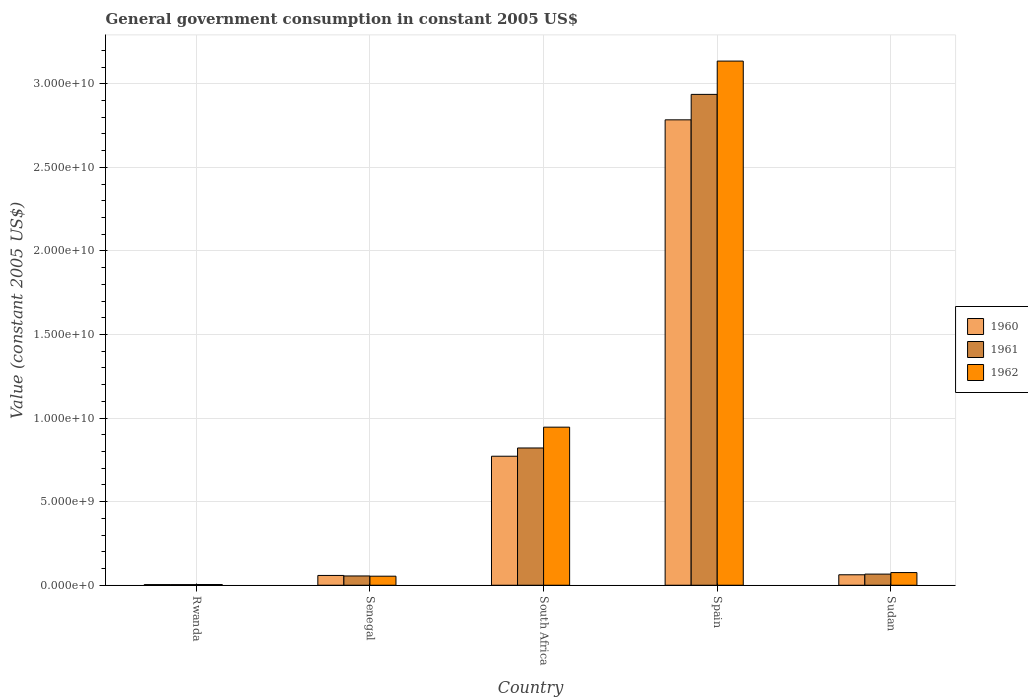Are the number of bars per tick equal to the number of legend labels?
Give a very brief answer. Yes. How many bars are there on the 5th tick from the left?
Ensure brevity in your answer.  3. How many bars are there on the 3rd tick from the right?
Offer a terse response. 3. What is the label of the 1st group of bars from the left?
Give a very brief answer. Rwanda. What is the government conusmption in 1960 in South Africa?
Your response must be concise. 7.72e+09. Across all countries, what is the maximum government conusmption in 1962?
Offer a terse response. 3.14e+1. Across all countries, what is the minimum government conusmption in 1961?
Ensure brevity in your answer.  3.79e+07. In which country was the government conusmption in 1960 minimum?
Ensure brevity in your answer.  Rwanda. What is the total government conusmption in 1960 in the graph?
Offer a terse response. 3.68e+1. What is the difference between the government conusmption in 1961 in Rwanda and that in Senegal?
Your answer should be very brief. -5.17e+08. What is the difference between the government conusmption in 1960 in Rwanda and the government conusmption in 1962 in South Africa?
Offer a very short reply. -9.42e+09. What is the average government conusmption in 1960 per country?
Provide a succinct answer. 7.36e+09. What is the difference between the government conusmption of/in 1961 and government conusmption of/in 1960 in Spain?
Keep it short and to the point. 1.52e+09. In how many countries, is the government conusmption in 1960 greater than 9000000000 US$?
Provide a succinct answer. 1. What is the ratio of the government conusmption in 1961 in Rwanda to that in Sudan?
Provide a succinct answer. 0.06. Is the government conusmption in 1962 in Rwanda less than that in Spain?
Provide a short and direct response. Yes. What is the difference between the highest and the second highest government conusmption in 1960?
Keep it short and to the point. -2.01e+1. What is the difference between the highest and the lowest government conusmption in 1960?
Offer a very short reply. 2.78e+1. What does the 1st bar from the left in Senegal represents?
Your response must be concise. 1960. What does the 1st bar from the right in Rwanda represents?
Make the answer very short. 1962. Is it the case that in every country, the sum of the government conusmption in 1962 and government conusmption in 1960 is greater than the government conusmption in 1961?
Give a very brief answer. Yes. What is the difference between two consecutive major ticks on the Y-axis?
Keep it short and to the point. 5.00e+09. Are the values on the major ticks of Y-axis written in scientific E-notation?
Give a very brief answer. Yes. Does the graph contain grids?
Provide a succinct answer. Yes. Where does the legend appear in the graph?
Keep it short and to the point. Center right. How many legend labels are there?
Ensure brevity in your answer.  3. What is the title of the graph?
Provide a succinct answer. General government consumption in constant 2005 US$. Does "1985" appear as one of the legend labels in the graph?
Offer a terse response. No. What is the label or title of the X-axis?
Provide a short and direct response. Country. What is the label or title of the Y-axis?
Your answer should be very brief. Value (constant 2005 US$). What is the Value (constant 2005 US$) of 1960 in Rwanda?
Ensure brevity in your answer.  3.93e+07. What is the Value (constant 2005 US$) of 1961 in Rwanda?
Your answer should be very brief. 3.79e+07. What is the Value (constant 2005 US$) in 1962 in Rwanda?
Offer a very short reply. 4.39e+07. What is the Value (constant 2005 US$) of 1960 in Senegal?
Offer a very short reply. 5.86e+08. What is the Value (constant 2005 US$) of 1961 in Senegal?
Offer a terse response. 5.55e+08. What is the Value (constant 2005 US$) in 1962 in Senegal?
Offer a very short reply. 5.41e+08. What is the Value (constant 2005 US$) in 1960 in South Africa?
Provide a short and direct response. 7.72e+09. What is the Value (constant 2005 US$) of 1961 in South Africa?
Your answer should be compact. 8.21e+09. What is the Value (constant 2005 US$) in 1962 in South Africa?
Make the answer very short. 9.46e+09. What is the Value (constant 2005 US$) of 1960 in Spain?
Offer a terse response. 2.78e+1. What is the Value (constant 2005 US$) of 1961 in Spain?
Your answer should be compact. 2.94e+1. What is the Value (constant 2005 US$) of 1962 in Spain?
Provide a succinct answer. 3.14e+1. What is the Value (constant 2005 US$) in 1960 in Sudan?
Your answer should be compact. 6.26e+08. What is the Value (constant 2005 US$) in 1961 in Sudan?
Your answer should be very brief. 6.66e+08. What is the Value (constant 2005 US$) of 1962 in Sudan?
Offer a terse response. 7.58e+08. Across all countries, what is the maximum Value (constant 2005 US$) of 1960?
Ensure brevity in your answer.  2.78e+1. Across all countries, what is the maximum Value (constant 2005 US$) of 1961?
Offer a terse response. 2.94e+1. Across all countries, what is the maximum Value (constant 2005 US$) of 1962?
Offer a very short reply. 3.14e+1. Across all countries, what is the minimum Value (constant 2005 US$) in 1960?
Give a very brief answer. 3.93e+07. Across all countries, what is the minimum Value (constant 2005 US$) in 1961?
Your response must be concise. 3.79e+07. Across all countries, what is the minimum Value (constant 2005 US$) in 1962?
Make the answer very short. 4.39e+07. What is the total Value (constant 2005 US$) in 1960 in the graph?
Make the answer very short. 3.68e+1. What is the total Value (constant 2005 US$) in 1961 in the graph?
Offer a very short reply. 3.88e+1. What is the total Value (constant 2005 US$) in 1962 in the graph?
Keep it short and to the point. 4.22e+1. What is the difference between the Value (constant 2005 US$) of 1960 in Rwanda and that in Senegal?
Keep it short and to the point. -5.47e+08. What is the difference between the Value (constant 2005 US$) of 1961 in Rwanda and that in Senegal?
Ensure brevity in your answer.  -5.17e+08. What is the difference between the Value (constant 2005 US$) in 1962 in Rwanda and that in Senegal?
Provide a succinct answer. -4.97e+08. What is the difference between the Value (constant 2005 US$) in 1960 in Rwanda and that in South Africa?
Make the answer very short. -7.68e+09. What is the difference between the Value (constant 2005 US$) of 1961 in Rwanda and that in South Africa?
Offer a terse response. -8.17e+09. What is the difference between the Value (constant 2005 US$) in 1962 in Rwanda and that in South Africa?
Give a very brief answer. -9.41e+09. What is the difference between the Value (constant 2005 US$) of 1960 in Rwanda and that in Spain?
Your response must be concise. -2.78e+1. What is the difference between the Value (constant 2005 US$) of 1961 in Rwanda and that in Spain?
Provide a short and direct response. -2.93e+1. What is the difference between the Value (constant 2005 US$) of 1962 in Rwanda and that in Spain?
Keep it short and to the point. -3.13e+1. What is the difference between the Value (constant 2005 US$) in 1960 in Rwanda and that in Sudan?
Make the answer very short. -5.86e+08. What is the difference between the Value (constant 2005 US$) of 1961 in Rwanda and that in Sudan?
Provide a succinct answer. -6.28e+08. What is the difference between the Value (constant 2005 US$) in 1962 in Rwanda and that in Sudan?
Ensure brevity in your answer.  -7.14e+08. What is the difference between the Value (constant 2005 US$) of 1960 in Senegal and that in South Africa?
Make the answer very short. -7.13e+09. What is the difference between the Value (constant 2005 US$) of 1961 in Senegal and that in South Africa?
Your response must be concise. -7.66e+09. What is the difference between the Value (constant 2005 US$) of 1962 in Senegal and that in South Africa?
Offer a terse response. -8.92e+09. What is the difference between the Value (constant 2005 US$) in 1960 in Senegal and that in Spain?
Your answer should be compact. -2.73e+1. What is the difference between the Value (constant 2005 US$) in 1961 in Senegal and that in Spain?
Your response must be concise. -2.88e+1. What is the difference between the Value (constant 2005 US$) of 1962 in Senegal and that in Spain?
Your answer should be very brief. -3.08e+1. What is the difference between the Value (constant 2005 US$) of 1960 in Senegal and that in Sudan?
Provide a succinct answer. -3.97e+07. What is the difference between the Value (constant 2005 US$) of 1961 in Senegal and that in Sudan?
Offer a terse response. -1.11e+08. What is the difference between the Value (constant 2005 US$) in 1962 in Senegal and that in Sudan?
Offer a terse response. -2.17e+08. What is the difference between the Value (constant 2005 US$) of 1960 in South Africa and that in Spain?
Provide a short and direct response. -2.01e+1. What is the difference between the Value (constant 2005 US$) of 1961 in South Africa and that in Spain?
Provide a short and direct response. -2.12e+1. What is the difference between the Value (constant 2005 US$) in 1962 in South Africa and that in Spain?
Offer a very short reply. -2.19e+1. What is the difference between the Value (constant 2005 US$) in 1960 in South Africa and that in Sudan?
Make the answer very short. 7.09e+09. What is the difference between the Value (constant 2005 US$) of 1961 in South Africa and that in Sudan?
Keep it short and to the point. 7.55e+09. What is the difference between the Value (constant 2005 US$) in 1962 in South Africa and that in Sudan?
Offer a very short reply. 8.70e+09. What is the difference between the Value (constant 2005 US$) of 1960 in Spain and that in Sudan?
Keep it short and to the point. 2.72e+1. What is the difference between the Value (constant 2005 US$) in 1961 in Spain and that in Sudan?
Keep it short and to the point. 2.87e+1. What is the difference between the Value (constant 2005 US$) of 1962 in Spain and that in Sudan?
Ensure brevity in your answer.  3.06e+1. What is the difference between the Value (constant 2005 US$) of 1960 in Rwanda and the Value (constant 2005 US$) of 1961 in Senegal?
Keep it short and to the point. -5.16e+08. What is the difference between the Value (constant 2005 US$) of 1960 in Rwanda and the Value (constant 2005 US$) of 1962 in Senegal?
Your answer should be compact. -5.01e+08. What is the difference between the Value (constant 2005 US$) in 1961 in Rwanda and the Value (constant 2005 US$) in 1962 in Senegal?
Offer a very short reply. -5.03e+08. What is the difference between the Value (constant 2005 US$) of 1960 in Rwanda and the Value (constant 2005 US$) of 1961 in South Africa?
Offer a terse response. -8.17e+09. What is the difference between the Value (constant 2005 US$) of 1960 in Rwanda and the Value (constant 2005 US$) of 1962 in South Africa?
Provide a succinct answer. -9.42e+09. What is the difference between the Value (constant 2005 US$) in 1961 in Rwanda and the Value (constant 2005 US$) in 1962 in South Africa?
Your answer should be very brief. -9.42e+09. What is the difference between the Value (constant 2005 US$) in 1960 in Rwanda and the Value (constant 2005 US$) in 1961 in Spain?
Offer a very short reply. -2.93e+1. What is the difference between the Value (constant 2005 US$) of 1960 in Rwanda and the Value (constant 2005 US$) of 1962 in Spain?
Keep it short and to the point. -3.13e+1. What is the difference between the Value (constant 2005 US$) of 1961 in Rwanda and the Value (constant 2005 US$) of 1962 in Spain?
Offer a terse response. -3.13e+1. What is the difference between the Value (constant 2005 US$) in 1960 in Rwanda and the Value (constant 2005 US$) in 1961 in Sudan?
Your answer should be very brief. -6.27e+08. What is the difference between the Value (constant 2005 US$) of 1960 in Rwanda and the Value (constant 2005 US$) of 1962 in Sudan?
Make the answer very short. -7.19e+08. What is the difference between the Value (constant 2005 US$) of 1961 in Rwanda and the Value (constant 2005 US$) of 1962 in Sudan?
Keep it short and to the point. -7.20e+08. What is the difference between the Value (constant 2005 US$) in 1960 in Senegal and the Value (constant 2005 US$) in 1961 in South Africa?
Your answer should be compact. -7.63e+09. What is the difference between the Value (constant 2005 US$) of 1960 in Senegal and the Value (constant 2005 US$) of 1962 in South Africa?
Keep it short and to the point. -8.87e+09. What is the difference between the Value (constant 2005 US$) in 1961 in Senegal and the Value (constant 2005 US$) in 1962 in South Africa?
Offer a very short reply. -8.90e+09. What is the difference between the Value (constant 2005 US$) in 1960 in Senegal and the Value (constant 2005 US$) in 1961 in Spain?
Make the answer very short. -2.88e+1. What is the difference between the Value (constant 2005 US$) in 1960 in Senegal and the Value (constant 2005 US$) in 1962 in Spain?
Ensure brevity in your answer.  -3.08e+1. What is the difference between the Value (constant 2005 US$) in 1961 in Senegal and the Value (constant 2005 US$) in 1962 in Spain?
Give a very brief answer. -3.08e+1. What is the difference between the Value (constant 2005 US$) in 1960 in Senegal and the Value (constant 2005 US$) in 1961 in Sudan?
Your answer should be very brief. -8.05e+07. What is the difference between the Value (constant 2005 US$) of 1960 in Senegal and the Value (constant 2005 US$) of 1962 in Sudan?
Ensure brevity in your answer.  -1.72e+08. What is the difference between the Value (constant 2005 US$) of 1961 in Senegal and the Value (constant 2005 US$) of 1962 in Sudan?
Your response must be concise. -2.03e+08. What is the difference between the Value (constant 2005 US$) in 1960 in South Africa and the Value (constant 2005 US$) in 1961 in Spain?
Keep it short and to the point. -2.16e+1. What is the difference between the Value (constant 2005 US$) in 1960 in South Africa and the Value (constant 2005 US$) in 1962 in Spain?
Your response must be concise. -2.36e+1. What is the difference between the Value (constant 2005 US$) of 1961 in South Africa and the Value (constant 2005 US$) of 1962 in Spain?
Provide a succinct answer. -2.31e+1. What is the difference between the Value (constant 2005 US$) of 1960 in South Africa and the Value (constant 2005 US$) of 1961 in Sudan?
Give a very brief answer. 7.05e+09. What is the difference between the Value (constant 2005 US$) in 1960 in South Africa and the Value (constant 2005 US$) in 1962 in Sudan?
Your response must be concise. 6.96e+09. What is the difference between the Value (constant 2005 US$) of 1961 in South Africa and the Value (constant 2005 US$) of 1962 in Sudan?
Offer a terse response. 7.45e+09. What is the difference between the Value (constant 2005 US$) in 1960 in Spain and the Value (constant 2005 US$) in 1961 in Sudan?
Offer a terse response. 2.72e+1. What is the difference between the Value (constant 2005 US$) in 1960 in Spain and the Value (constant 2005 US$) in 1962 in Sudan?
Keep it short and to the point. 2.71e+1. What is the difference between the Value (constant 2005 US$) of 1961 in Spain and the Value (constant 2005 US$) of 1962 in Sudan?
Provide a succinct answer. 2.86e+1. What is the average Value (constant 2005 US$) of 1960 per country?
Ensure brevity in your answer.  7.36e+09. What is the average Value (constant 2005 US$) in 1961 per country?
Provide a short and direct response. 7.77e+09. What is the average Value (constant 2005 US$) in 1962 per country?
Provide a succinct answer. 8.43e+09. What is the difference between the Value (constant 2005 US$) of 1960 and Value (constant 2005 US$) of 1961 in Rwanda?
Provide a succinct answer. 1.39e+06. What is the difference between the Value (constant 2005 US$) of 1960 and Value (constant 2005 US$) of 1962 in Rwanda?
Make the answer very short. -4.55e+06. What is the difference between the Value (constant 2005 US$) in 1961 and Value (constant 2005 US$) in 1962 in Rwanda?
Make the answer very short. -5.95e+06. What is the difference between the Value (constant 2005 US$) of 1960 and Value (constant 2005 US$) of 1961 in Senegal?
Your response must be concise. 3.05e+07. What is the difference between the Value (constant 2005 US$) of 1960 and Value (constant 2005 US$) of 1962 in Senegal?
Make the answer very short. 4.51e+07. What is the difference between the Value (constant 2005 US$) of 1961 and Value (constant 2005 US$) of 1962 in Senegal?
Offer a terse response. 1.45e+07. What is the difference between the Value (constant 2005 US$) in 1960 and Value (constant 2005 US$) in 1961 in South Africa?
Provide a succinct answer. -4.93e+08. What is the difference between the Value (constant 2005 US$) of 1960 and Value (constant 2005 US$) of 1962 in South Africa?
Your answer should be very brief. -1.74e+09. What is the difference between the Value (constant 2005 US$) of 1961 and Value (constant 2005 US$) of 1962 in South Africa?
Provide a short and direct response. -1.25e+09. What is the difference between the Value (constant 2005 US$) in 1960 and Value (constant 2005 US$) in 1961 in Spain?
Your answer should be compact. -1.52e+09. What is the difference between the Value (constant 2005 US$) of 1960 and Value (constant 2005 US$) of 1962 in Spain?
Keep it short and to the point. -3.51e+09. What is the difference between the Value (constant 2005 US$) in 1961 and Value (constant 2005 US$) in 1962 in Spain?
Provide a short and direct response. -1.99e+09. What is the difference between the Value (constant 2005 US$) of 1960 and Value (constant 2005 US$) of 1961 in Sudan?
Make the answer very short. -4.08e+07. What is the difference between the Value (constant 2005 US$) in 1960 and Value (constant 2005 US$) in 1962 in Sudan?
Provide a succinct answer. -1.33e+08. What is the difference between the Value (constant 2005 US$) in 1961 and Value (constant 2005 US$) in 1962 in Sudan?
Make the answer very short. -9.18e+07. What is the ratio of the Value (constant 2005 US$) of 1960 in Rwanda to that in Senegal?
Provide a succinct answer. 0.07. What is the ratio of the Value (constant 2005 US$) of 1961 in Rwanda to that in Senegal?
Offer a terse response. 0.07. What is the ratio of the Value (constant 2005 US$) in 1962 in Rwanda to that in Senegal?
Make the answer very short. 0.08. What is the ratio of the Value (constant 2005 US$) in 1960 in Rwanda to that in South Africa?
Your answer should be very brief. 0.01. What is the ratio of the Value (constant 2005 US$) of 1961 in Rwanda to that in South Africa?
Offer a terse response. 0. What is the ratio of the Value (constant 2005 US$) in 1962 in Rwanda to that in South Africa?
Your answer should be compact. 0. What is the ratio of the Value (constant 2005 US$) in 1960 in Rwanda to that in Spain?
Your answer should be compact. 0. What is the ratio of the Value (constant 2005 US$) of 1961 in Rwanda to that in Spain?
Your answer should be compact. 0. What is the ratio of the Value (constant 2005 US$) of 1962 in Rwanda to that in Spain?
Provide a succinct answer. 0. What is the ratio of the Value (constant 2005 US$) of 1960 in Rwanda to that in Sudan?
Give a very brief answer. 0.06. What is the ratio of the Value (constant 2005 US$) in 1961 in Rwanda to that in Sudan?
Ensure brevity in your answer.  0.06. What is the ratio of the Value (constant 2005 US$) in 1962 in Rwanda to that in Sudan?
Keep it short and to the point. 0.06. What is the ratio of the Value (constant 2005 US$) of 1960 in Senegal to that in South Africa?
Keep it short and to the point. 0.08. What is the ratio of the Value (constant 2005 US$) of 1961 in Senegal to that in South Africa?
Your answer should be very brief. 0.07. What is the ratio of the Value (constant 2005 US$) of 1962 in Senegal to that in South Africa?
Your answer should be very brief. 0.06. What is the ratio of the Value (constant 2005 US$) of 1960 in Senegal to that in Spain?
Ensure brevity in your answer.  0.02. What is the ratio of the Value (constant 2005 US$) in 1961 in Senegal to that in Spain?
Your answer should be very brief. 0.02. What is the ratio of the Value (constant 2005 US$) of 1962 in Senegal to that in Spain?
Offer a terse response. 0.02. What is the ratio of the Value (constant 2005 US$) of 1960 in Senegal to that in Sudan?
Offer a very short reply. 0.94. What is the ratio of the Value (constant 2005 US$) in 1961 in Senegal to that in Sudan?
Ensure brevity in your answer.  0.83. What is the ratio of the Value (constant 2005 US$) in 1962 in Senegal to that in Sudan?
Provide a short and direct response. 0.71. What is the ratio of the Value (constant 2005 US$) in 1960 in South Africa to that in Spain?
Provide a short and direct response. 0.28. What is the ratio of the Value (constant 2005 US$) of 1961 in South Africa to that in Spain?
Keep it short and to the point. 0.28. What is the ratio of the Value (constant 2005 US$) of 1962 in South Africa to that in Spain?
Ensure brevity in your answer.  0.3. What is the ratio of the Value (constant 2005 US$) of 1960 in South Africa to that in Sudan?
Offer a terse response. 12.34. What is the ratio of the Value (constant 2005 US$) of 1961 in South Africa to that in Sudan?
Provide a succinct answer. 12.32. What is the ratio of the Value (constant 2005 US$) in 1962 in South Africa to that in Sudan?
Keep it short and to the point. 12.47. What is the ratio of the Value (constant 2005 US$) in 1960 in Spain to that in Sudan?
Your response must be concise. 44.51. What is the ratio of the Value (constant 2005 US$) in 1961 in Spain to that in Sudan?
Offer a very short reply. 44.07. What is the ratio of the Value (constant 2005 US$) of 1962 in Spain to that in Sudan?
Your response must be concise. 41.36. What is the difference between the highest and the second highest Value (constant 2005 US$) in 1960?
Make the answer very short. 2.01e+1. What is the difference between the highest and the second highest Value (constant 2005 US$) of 1961?
Ensure brevity in your answer.  2.12e+1. What is the difference between the highest and the second highest Value (constant 2005 US$) in 1962?
Your answer should be very brief. 2.19e+1. What is the difference between the highest and the lowest Value (constant 2005 US$) of 1960?
Your answer should be compact. 2.78e+1. What is the difference between the highest and the lowest Value (constant 2005 US$) in 1961?
Ensure brevity in your answer.  2.93e+1. What is the difference between the highest and the lowest Value (constant 2005 US$) in 1962?
Offer a terse response. 3.13e+1. 